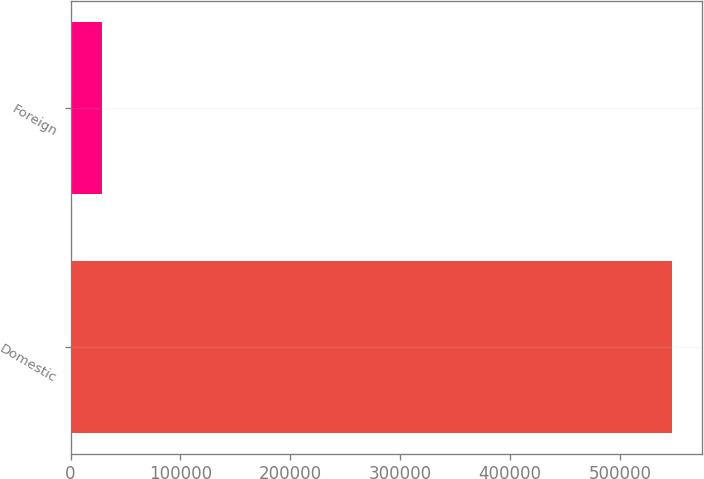Convert chart to OTSL. <chart><loc_0><loc_0><loc_500><loc_500><bar_chart><fcel>Domestic<fcel>Foreign<nl><fcel>547535<fcel>28535<nl></chart> 